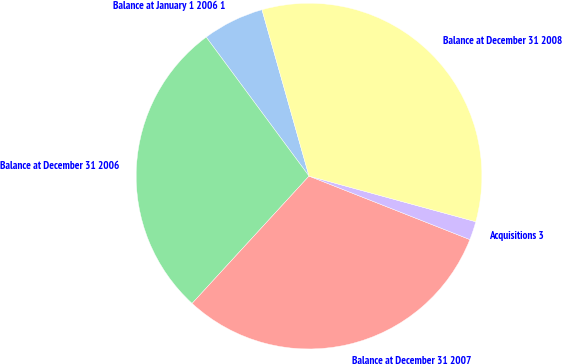Convert chart. <chart><loc_0><loc_0><loc_500><loc_500><pie_chart><fcel>Balance at January 1 2006 1<fcel>Balance at December 31 2006<fcel>Balance at December 31 2007<fcel>Acquisitions 3<fcel>Balance at December 31 2008<nl><fcel>5.75%<fcel>28.04%<fcel>30.84%<fcel>1.73%<fcel>33.64%<nl></chart> 